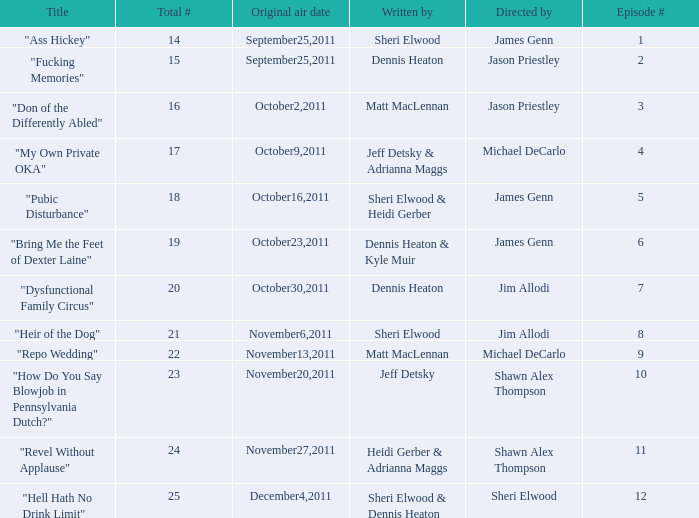How many different episode numbers are there for the episodes directed by Sheri Elwood? 1.0. 